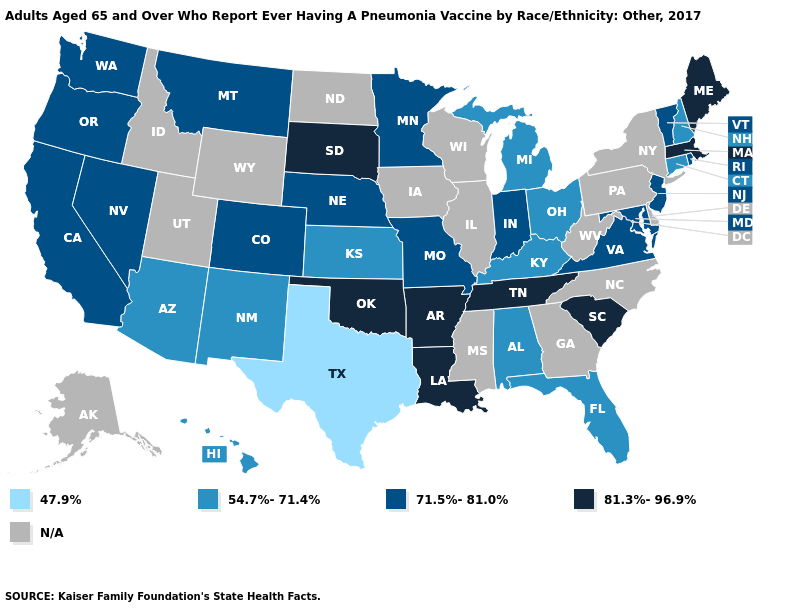Does Rhode Island have the lowest value in the USA?
Be succinct. No. Does Maine have the highest value in the Northeast?
Give a very brief answer. Yes. Does the map have missing data?
Keep it brief. Yes. Does California have the highest value in the USA?
Write a very short answer. No. What is the highest value in states that border Arizona?
Be succinct. 71.5%-81.0%. What is the highest value in the South ?
Keep it brief. 81.3%-96.9%. Name the states that have a value in the range 54.7%-71.4%?
Keep it brief. Alabama, Arizona, Connecticut, Florida, Hawaii, Kansas, Kentucky, Michigan, New Hampshire, New Mexico, Ohio. What is the value of California?
Be succinct. 71.5%-81.0%. Among the states that border Missouri , does Kentucky have the lowest value?
Short answer required. Yes. Does the map have missing data?
Answer briefly. Yes. What is the value of Ohio?
Write a very short answer. 54.7%-71.4%. Does Maine have the lowest value in the USA?
Give a very brief answer. No. Does Kentucky have the highest value in the South?
Keep it brief. No. 